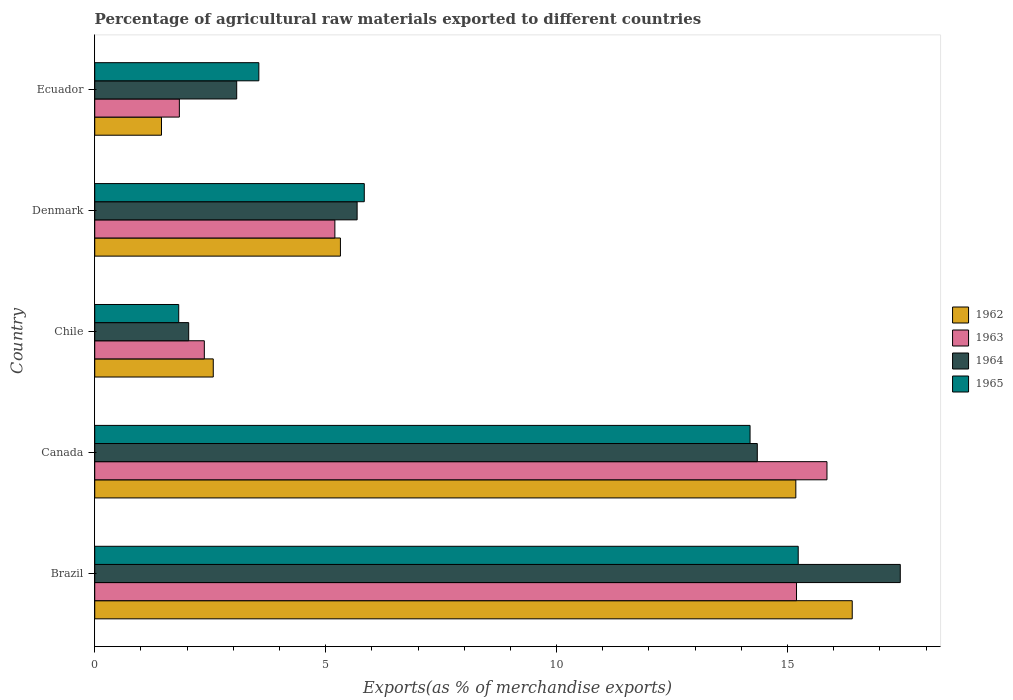How many different coloured bars are there?
Your answer should be very brief. 4. How many groups of bars are there?
Your response must be concise. 5. Are the number of bars on each tick of the Y-axis equal?
Provide a succinct answer. Yes. How many bars are there on the 1st tick from the top?
Offer a terse response. 4. How many bars are there on the 4th tick from the bottom?
Ensure brevity in your answer.  4. What is the label of the 3rd group of bars from the top?
Ensure brevity in your answer.  Chile. In how many cases, is the number of bars for a given country not equal to the number of legend labels?
Your answer should be compact. 0. What is the percentage of exports to different countries in 1965 in Canada?
Your response must be concise. 14.19. Across all countries, what is the maximum percentage of exports to different countries in 1962?
Your response must be concise. 16.4. Across all countries, what is the minimum percentage of exports to different countries in 1962?
Provide a succinct answer. 1.45. In which country was the percentage of exports to different countries in 1965 maximum?
Make the answer very short. Brazil. What is the total percentage of exports to different countries in 1963 in the graph?
Your answer should be compact. 40.46. What is the difference between the percentage of exports to different countries in 1965 in Brazil and that in Canada?
Ensure brevity in your answer.  1.04. What is the difference between the percentage of exports to different countries in 1962 in Chile and the percentage of exports to different countries in 1963 in Brazil?
Offer a terse response. -12.63. What is the average percentage of exports to different countries in 1964 per country?
Keep it short and to the point. 8.52. What is the difference between the percentage of exports to different countries in 1965 and percentage of exports to different countries in 1963 in Brazil?
Give a very brief answer. 0.04. What is the ratio of the percentage of exports to different countries in 1965 in Brazil to that in Ecuador?
Ensure brevity in your answer.  4.29. Is the percentage of exports to different countries in 1965 in Canada less than that in Denmark?
Ensure brevity in your answer.  No. Is the difference between the percentage of exports to different countries in 1965 in Brazil and Ecuador greater than the difference between the percentage of exports to different countries in 1963 in Brazil and Ecuador?
Offer a terse response. No. What is the difference between the highest and the second highest percentage of exports to different countries in 1965?
Your answer should be compact. 1.04. What is the difference between the highest and the lowest percentage of exports to different countries in 1962?
Offer a very short reply. 14.96. Is the sum of the percentage of exports to different countries in 1965 in Brazil and Chile greater than the maximum percentage of exports to different countries in 1964 across all countries?
Provide a short and direct response. No. Is it the case that in every country, the sum of the percentage of exports to different countries in 1963 and percentage of exports to different countries in 1965 is greater than the sum of percentage of exports to different countries in 1964 and percentage of exports to different countries in 1962?
Offer a very short reply. No. What does the 1st bar from the top in Denmark represents?
Provide a short and direct response. 1965. What does the 3rd bar from the bottom in Denmark represents?
Ensure brevity in your answer.  1964. How many bars are there?
Provide a short and direct response. 20. Are all the bars in the graph horizontal?
Your response must be concise. Yes. How many countries are there in the graph?
Provide a short and direct response. 5. What is the difference between two consecutive major ticks on the X-axis?
Make the answer very short. 5. Does the graph contain grids?
Provide a succinct answer. No. How are the legend labels stacked?
Provide a succinct answer. Vertical. What is the title of the graph?
Your response must be concise. Percentage of agricultural raw materials exported to different countries. Does "1984" appear as one of the legend labels in the graph?
Keep it short and to the point. No. What is the label or title of the X-axis?
Give a very brief answer. Exports(as % of merchandise exports). What is the Exports(as % of merchandise exports) of 1962 in Brazil?
Your answer should be very brief. 16.4. What is the Exports(as % of merchandise exports) in 1963 in Brazil?
Your response must be concise. 15.2. What is the Exports(as % of merchandise exports) of 1964 in Brazil?
Provide a succinct answer. 17.44. What is the Exports(as % of merchandise exports) of 1965 in Brazil?
Provide a short and direct response. 15.23. What is the Exports(as % of merchandise exports) of 1962 in Canada?
Provide a short and direct response. 15.18. What is the Exports(as % of merchandise exports) of 1963 in Canada?
Offer a very short reply. 15.85. What is the Exports(as % of merchandise exports) of 1964 in Canada?
Offer a terse response. 14.35. What is the Exports(as % of merchandise exports) of 1965 in Canada?
Offer a very short reply. 14.19. What is the Exports(as % of merchandise exports) of 1962 in Chile?
Your answer should be very brief. 2.57. What is the Exports(as % of merchandise exports) in 1963 in Chile?
Provide a short and direct response. 2.37. What is the Exports(as % of merchandise exports) in 1964 in Chile?
Offer a terse response. 2.03. What is the Exports(as % of merchandise exports) in 1965 in Chile?
Your answer should be very brief. 1.82. What is the Exports(as % of merchandise exports) in 1962 in Denmark?
Ensure brevity in your answer.  5.32. What is the Exports(as % of merchandise exports) in 1963 in Denmark?
Provide a succinct answer. 5.2. What is the Exports(as % of merchandise exports) in 1964 in Denmark?
Provide a short and direct response. 5.68. What is the Exports(as % of merchandise exports) in 1965 in Denmark?
Offer a very short reply. 5.84. What is the Exports(as % of merchandise exports) in 1962 in Ecuador?
Keep it short and to the point. 1.45. What is the Exports(as % of merchandise exports) in 1963 in Ecuador?
Give a very brief answer. 1.83. What is the Exports(as % of merchandise exports) of 1964 in Ecuador?
Give a very brief answer. 3.07. What is the Exports(as % of merchandise exports) of 1965 in Ecuador?
Make the answer very short. 3.55. Across all countries, what is the maximum Exports(as % of merchandise exports) of 1962?
Make the answer very short. 16.4. Across all countries, what is the maximum Exports(as % of merchandise exports) in 1963?
Ensure brevity in your answer.  15.85. Across all countries, what is the maximum Exports(as % of merchandise exports) in 1964?
Your answer should be compact. 17.44. Across all countries, what is the maximum Exports(as % of merchandise exports) in 1965?
Give a very brief answer. 15.23. Across all countries, what is the minimum Exports(as % of merchandise exports) in 1962?
Provide a short and direct response. 1.45. Across all countries, what is the minimum Exports(as % of merchandise exports) of 1963?
Make the answer very short. 1.83. Across all countries, what is the minimum Exports(as % of merchandise exports) of 1964?
Offer a terse response. 2.03. Across all countries, what is the minimum Exports(as % of merchandise exports) of 1965?
Ensure brevity in your answer.  1.82. What is the total Exports(as % of merchandise exports) in 1962 in the graph?
Your answer should be very brief. 40.91. What is the total Exports(as % of merchandise exports) of 1963 in the graph?
Offer a very short reply. 40.46. What is the total Exports(as % of merchandise exports) in 1964 in the graph?
Provide a short and direct response. 42.58. What is the total Exports(as % of merchandise exports) of 1965 in the graph?
Your answer should be compact. 40.63. What is the difference between the Exports(as % of merchandise exports) of 1962 in Brazil and that in Canada?
Keep it short and to the point. 1.22. What is the difference between the Exports(as % of merchandise exports) of 1963 in Brazil and that in Canada?
Your answer should be very brief. -0.66. What is the difference between the Exports(as % of merchandise exports) in 1964 in Brazil and that in Canada?
Make the answer very short. 3.1. What is the difference between the Exports(as % of merchandise exports) of 1965 in Brazil and that in Canada?
Provide a short and direct response. 1.04. What is the difference between the Exports(as % of merchandise exports) in 1962 in Brazil and that in Chile?
Offer a terse response. 13.84. What is the difference between the Exports(as % of merchandise exports) in 1963 in Brazil and that in Chile?
Offer a very short reply. 12.82. What is the difference between the Exports(as % of merchandise exports) of 1964 in Brazil and that in Chile?
Give a very brief answer. 15.41. What is the difference between the Exports(as % of merchandise exports) in 1965 in Brazil and that in Chile?
Keep it short and to the point. 13.41. What is the difference between the Exports(as % of merchandise exports) of 1962 in Brazil and that in Denmark?
Your response must be concise. 11.08. What is the difference between the Exports(as % of merchandise exports) in 1963 in Brazil and that in Denmark?
Offer a terse response. 10. What is the difference between the Exports(as % of merchandise exports) of 1964 in Brazil and that in Denmark?
Your response must be concise. 11.76. What is the difference between the Exports(as % of merchandise exports) in 1965 in Brazil and that in Denmark?
Ensure brevity in your answer.  9.4. What is the difference between the Exports(as % of merchandise exports) in 1962 in Brazil and that in Ecuador?
Your response must be concise. 14.96. What is the difference between the Exports(as % of merchandise exports) of 1963 in Brazil and that in Ecuador?
Keep it short and to the point. 13.36. What is the difference between the Exports(as % of merchandise exports) in 1964 in Brazil and that in Ecuador?
Provide a short and direct response. 14.37. What is the difference between the Exports(as % of merchandise exports) of 1965 in Brazil and that in Ecuador?
Your answer should be very brief. 11.68. What is the difference between the Exports(as % of merchandise exports) in 1962 in Canada and that in Chile?
Make the answer very short. 12.61. What is the difference between the Exports(as % of merchandise exports) in 1963 in Canada and that in Chile?
Provide a short and direct response. 13.48. What is the difference between the Exports(as % of merchandise exports) in 1964 in Canada and that in Chile?
Offer a terse response. 12.31. What is the difference between the Exports(as % of merchandise exports) in 1965 in Canada and that in Chile?
Your answer should be very brief. 12.37. What is the difference between the Exports(as % of merchandise exports) of 1962 in Canada and that in Denmark?
Ensure brevity in your answer.  9.86. What is the difference between the Exports(as % of merchandise exports) in 1963 in Canada and that in Denmark?
Your response must be concise. 10.65. What is the difference between the Exports(as % of merchandise exports) of 1964 in Canada and that in Denmark?
Keep it short and to the point. 8.66. What is the difference between the Exports(as % of merchandise exports) of 1965 in Canada and that in Denmark?
Provide a succinct answer. 8.35. What is the difference between the Exports(as % of merchandise exports) in 1962 in Canada and that in Ecuador?
Give a very brief answer. 13.74. What is the difference between the Exports(as % of merchandise exports) in 1963 in Canada and that in Ecuador?
Your response must be concise. 14.02. What is the difference between the Exports(as % of merchandise exports) in 1964 in Canada and that in Ecuador?
Make the answer very short. 11.27. What is the difference between the Exports(as % of merchandise exports) in 1965 in Canada and that in Ecuador?
Your response must be concise. 10.64. What is the difference between the Exports(as % of merchandise exports) in 1962 in Chile and that in Denmark?
Give a very brief answer. -2.75. What is the difference between the Exports(as % of merchandise exports) in 1963 in Chile and that in Denmark?
Give a very brief answer. -2.83. What is the difference between the Exports(as % of merchandise exports) in 1964 in Chile and that in Denmark?
Offer a terse response. -3.65. What is the difference between the Exports(as % of merchandise exports) of 1965 in Chile and that in Denmark?
Your response must be concise. -4.02. What is the difference between the Exports(as % of merchandise exports) in 1962 in Chile and that in Ecuador?
Keep it short and to the point. 1.12. What is the difference between the Exports(as % of merchandise exports) of 1963 in Chile and that in Ecuador?
Your response must be concise. 0.54. What is the difference between the Exports(as % of merchandise exports) of 1964 in Chile and that in Ecuador?
Ensure brevity in your answer.  -1.04. What is the difference between the Exports(as % of merchandise exports) in 1965 in Chile and that in Ecuador?
Your answer should be very brief. -1.74. What is the difference between the Exports(as % of merchandise exports) of 1962 in Denmark and that in Ecuador?
Offer a terse response. 3.87. What is the difference between the Exports(as % of merchandise exports) of 1963 in Denmark and that in Ecuador?
Offer a very short reply. 3.37. What is the difference between the Exports(as % of merchandise exports) of 1964 in Denmark and that in Ecuador?
Your response must be concise. 2.61. What is the difference between the Exports(as % of merchandise exports) of 1965 in Denmark and that in Ecuador?
Offer a terse response. 2.28. What is the difference between the Exports(as % of merchandise exports) of 1962 in Brazil and the Exports(as % of merchandise exports) of 1963 in Canada?
Provide a short and direct response. 0.55. What is the difference between the Exports(as % of merchandise exports) in 1962 in Brazil and the Exports(as % of merchandise exports) in 1964 in Canada?
Make the answer very short. 2.06. What is the difference between the Exports(as % of merchandise exports) in 1962 in Brazil and the Exports(as % of merchandise exports) in 1965 in Canada?
Keep it short and to the point. 2.21. What is the difference between the Exports(as % of merchandise exports) in 1963 in Brazil and the Exports(as % of merchandise exports) in 1964 in Canada?
Your answer should be compact. 0.85. What is the difference between the Exports(as % of merchandise exports) of 1963 in Brazil and the Exports(as % of merchandise exports) of 1965 in Canada?
Ensure brevity in your answer.  1.01. What is the difference between the Exports(as % of merchandise exports) of 1964 in Brazil and the Exports(as % of merchandise exports) of 1965 in Canada?
Give a very brief answer. 3.25. What is the difference between the Exports(as % of merchandise exports) in 1962 in Brazil and the Exports(as % of merchandise exports) in 1963 in Chile?
Make the answer very short. 14.03. What is the difference between the Exports(as % of merchandise exports) in 1962 in Brazil and the Exports(as % of merchandise exports) in 1964 in Chile?
Your answer should be compact. 14.37. What is the difference between the Exports(as % of merchandise exports) of 1962 in Brazil and the Exports(as % of merchandise exports) of 1965 in Chile?
Your response must be concise. 14.58. What is the difference between the Exports(as % of merchandise exports) in 1963 in Brazil and the Exports(as % of merchandise exports) in 1964 in Chile?
Keep it short and to the point. 13.16. What is the difference between the Exports(as % of merchandise exports) of 1963 in Brazil and the Exports(as % of merchandise exports) of 1965 in Chile?
Provide a short and direct response. 13.38. What is the difference between the Exports(as % of merchandise exports) in 1964 in Brazil and the Exports(as % of merchandise exports) in 1965 in Chile?
Ensure brevity in your answer.  15.62. What is the difference between the Exports(as % of merchandise exports) of 1962 in Brazil and the Exports(as % of merchandise exports) of 1963 in Denmark?
Give a very brief answer. 11.2. What is the difference between the Exports(as % of merchandise exports) in 1962 in Brazil and the Exports(as % of merchandise exports) in 1964 in Denmark?
Keep it short and to the point. 10.72. What is the difference between the Exports(as % of merchandise exports) of 1962 in Brazil and the Exports(as % of merchandise exports) of 1965 in Denmark?
Make the answer very short. 10.57. What is the difference between the Exports(as % of merchandise exports) of 1963 in Brazil and the Exports(as % of merchandise exports) of 1964 in Denmark?
Your answer should be very brief. 9.51. What is the difference between the Exports(as % of merchandise exports) of 1963 in Brazil and the Exports(as % of merchandise exports) of 1965 in Denmark?
Your response must be concise. 9.36. What is the difference between the Exports(as % of merchandise exports) in 1964 in Brazil and the Exports(as % of merchandise exports) in 1965 in Denmark?
Keep it short and to the point. 11.61. What is the difference between the Exports(as % of merchandise exports) of 1962 in Brazil and the Exports(as % of merchandise exports) of 1963 in Ecuador?
Offer a terse response. 14.57. What is the difference between the Exports(as % of merchandise exports) of 1962 in Brazil and the Exports(as % of merchandise exports) of 1964 in Ecuador?
Your answer should be compact. 13.33. What is the difference between the Exports(as % of merchandise exports) of 1962 in Brazil and the Exports(as % of merchandise exports) of 1965 in Ecuador?
Make the answer very short. 12.85. What is the difference between the Exports(as % of merchandise exports) in 1963 in Brazil and the Exports(as % of merchandise exports) in 1964 in Ecuador?
Your response must be concise. 12.12. What is the difference between the Exports(as % of merchandise exports) in 1963 in Brazil and the Exports(as % of merchandise exports) in 1965 in Ecuador?
Keep it short and to the point. 11.64. What is the difference between the Exports(as % of merchandise exports) of 1964 in Brazil and the Exports(as % of merchandise exports) of 1965 in Ecuador?
Ensure brevity in your answer.  13.89. What is the difference between the Exports(as % of merchandise exports) in 1962 in Canada and the Exports(as % of merchandise exports) in 1963 in Chile?
Your answer should be very brief. 12.81. What is the difference between the Exports(as % of merchandise exports) in 1962 in Canada and the Exports(as % of merchandise exports) in 1964 in Chile?
Provide a succinct answer. 13.15. What is the difference between the Exports(as % of merchandise exports) of 1962 in Canada and the Exports(as % of merchandise exports) of 1965 in Chile?
Provide a short and direct response. 13.36. What is the difference between the Exports(as % of merchandise exports) of 1963 in Canada and the Exports(as % of merchandise exports) of 1964 in Chile?
Provide a short and direct response. 13.82. What is the difference between the Exports(as % of merchandise exports) in 1963 in Canada and the Exports(as % of merchandise exports) in 1965 in Chile?
Offer a terse response. 14.04. What is the difference between the Exports(as % of merchandise exports) in 1964 in Canada and the Exports(as % of merchandise exports) in 1965 in Chile?
Keep it short and to the point. 12.53. What is the difference between the Exports(as % of merchandise exports) of 1962 in Canada and the Exports(as % of merchandise exports) of 1963 in Denmark?
Give a very brief answer. 9.98. What is the difference between the Exports(as % of merchandise exports) of 1962 in Canada and the Exports(as % of merchandise exports) of 1964 in Denmark?
Your response must be concise. 9.5. What is the difference between the Exports(as % of merchandise exports) of 1962 in Canada and the Exports(as % of merchandise exports) of 1965 in Denmark?
Your answer should be compact. 9.34. What is the difference between the Exports(as % of merchandise exports) in 1963 in Canada and the Exports(as % of merchandise exports) in 1964 in Denmark?
Provide a succinct answer. 10.17. What is the difference between the Exports(as % of merchandise exports) of 1963 in Canada and the Exports(as % of merchandise exports) of 1965 in Denmark?
Offer a very short reply. 10.02. What is the difference between the Exports(as % of merchandise exports) in 1964 in Canada and the Exports(as % of merchandise exports) in 1965 in Denmark?
Keep it short and to the point. 8.51. What is the difference between the Exports(as % of merchandise exports) in 1962 in Canada and the Exports(as % of merchandise exports) in 1963 in Ecuador?
Keep it short and to the point. 13.35. What is the difference between the Exports(as % of merchandise exports) in 1962 in Canada and the Exports(as % of merchandise exports) in 1964 in Ecuador?
Offer a terse response. 12.11. What is the difference between the Exports(as % of merchandise exports) of 1962 in Canada and the Exports(as % of merchandise exports) of 1965 in Ecuador?
Provide a succinct answer. 11.63. What is the difference between the Exports(as % of merchandise exports) in 1963 in Canada and the Exports(as % of merchandise exports) in 1964 in Ecuador?
Make the answer very short. 12.78. What is the difference between the Exports(as % of merchandise exports) in 1963 in Canada and the Exports(as % of merchandise exports) in 1965 in Ecuador?
Offer a terse response. 12.3. What is the difference between the Exports(as % of merchandise exports) in 1964 in Canada and the Exports(as % of merchandise exports) in 1965 in Ecuador?
Offer a terse response. 10.79. What is the difference between the Exports(as % of merchandise exports) in 1962 in Chile and the Exports(as % of merchandise exports) in 1963 in Denmark?
Your answer should be compact. -2.63. What is the difference between the Exports(as % of merchandise exports) of 1962 in Chile and the Exports(as % of merchandise exports) of 1964 in Denmark?
Provide a short and direct response. -3.11. What is the difference between the Exports(as % of merchandise exports) in 1962 in Chile and the Exports(as % of merchandise exports) in 1965 in Denmark?
Your response must be concise. -3.27. What is the difference between the Exports(as % of merchandise exports) in 1963 in Chile and the Exports(as % of merchandise exports) in 1964 in Denmark?
Give a very brief answer. -3.31. What is the difference between the Exports(as % of merchandise exports) of 1963 in Chile and the Exports(as % of merchandise exports) of 1965 in Denmark?
Make the answer very short. -3.46. What is the difference between the Exports(as % of merchandise exports) in 1964 in Chile and the Exports(as % of merchandise exports) in 1965 in Denmark?
Provide a succinct answer. -3.8. What is the difference between the Exports(as % of merchandise exports) in 1962 in Chile and the Exports(as % of merchandise exports) in 1963 in Ecuador?
Your response must be concise. 0.73. What is the difference between the Exports(as % of merchandise exports) of 1962 in Chile and the Exports(as % of merchandise exports) of 1964 in Ecuador?
Your response must be concise. -0.51. What is the difference between the Exports(as % of merchandise exports) of 1962 in Chile and the Exports(as % of merchandise exports) of 1965 in Ecuador?
Keep it short and to the point. -0.99. What is the difference between the Exports(as % of merchandise exports) of 1963 in Chile and the Exports(as % of merchandise exports) of 1964 in Ecuador?
Offer a very short reply. -0.7. What is the difference between the Exports(as % of merchandise exports) of 1963 in Chile and the Exports(as % of merchandise exports) of 1965 in Ecuador?
Offer a very short reply. -1.18. What is the difference between the Exports(as % of merchandise exports) in 1964 in Chile and the Exports(as % of merchandise exports) in 1965 in Ecuador?
Your answer should be compact. -1.52. What is the difference between the Exports(as % of merchandise exports) in 1962 in Denmark and the Exports(as % of merchandise exports) in 1963 in Ecuador?
Your answer should be compact. 3.49. What is the difference between the Exports(as % of merchandise exports) in 1962 in Denmark and the Exports(as % of merchandise exports) in 1964 in Ecuador?
Your answer should be compact. 2.25. What is the difference between the Exports(as % of merchandise exports) in 1962 in Denmark and the Exports(as % of merchandise exports) in 1965 in Ecuador?
Your answer should be very brief. 1.77. What is the difference between the Exports(as % of merchandise exports) of 1963 in Denmark and the Exports(as % of merchandise exports) of 1964 in Ecuador?
Provide a succinct answer. 2.13. What is the difference between the Exports(as % of merchandise exports) in 1963 in Denmark and the Exports(as % of merchandise exports) in 1965 in Ecuador?
Your answer should be very brief. 1.65. What is the difference between the Exports(as % of merchandise exports) in 1964 in Denmark and the Exports(as % of merchandise exports) in 1965 in Ecuador?
Your answer should be compact. 2.13. What is the average Exports(as % of merchandise exports) in 1962 per country?
Your answer should be compact. 8.18. What is the average Exports(as % of merchandise exports) of 1963 per country?
Provide a short and direct response. 8.09. What is the average Exports(as % of merchandise exports) in 1964 per country?
Give a very brief answer. 8.52. What is the average Exports(as % of merchandise exports) in 1965 per country?
Your response must be concise. 8.13. What is the difference between the Exports(as % of merchandise exports) in 1962 and Exports(as % of merchandise exports) in 1963 in Brazil?
Provide a short and direct response. 1.21. What is the difference between the Exports(as % of merchandise exports) in 1962 and Exports(as % of merchandise exports) in 1964 in Brazil?
Ensure brevity in your answer.  -1.04. What is the difference between the Exports(as % of merchandise exports) in 1962 and Exports(as % of merchandise exports) in 1965 in Brazil?
Provide a short and direct response. 1.17. What is the difference between the Exports(as % of merchandise exports) in 1963 and Exports(as % of merchandise exports) in 1964 in Brazil?
Make the answer very short. -2.25. What is the difference between the Exports(as % of merchandise exports) of 1963 and Exports(as % of merchandise exports) of 1965 in Brazil?
Offer a very short reply. -0.04. What is the difference between the Exports(as % of merchandise exports) in 1964 and Exports(as % of merchandise exports) in 1965 in Brazil?
Ensure brevity in your answer.  2.21. What is the difference between the Exports(as % of merchandise exports) of 1962 and Exports(as % of merchandise exports) of 1963 in Canada?
Your response must be concise. -0.67. What is the difference between the Exports(as % of merchandise exports) in 1962 and Exports(as % of merchandise exports) in 1964 in Canada?
Offer a very short reply. 0.83. What is the difference between the Exports(as % of merchandise exports) in 1963 and Exports(as % of merchandise exports) in 1964 in Canada?
Provide a short and direct response. 1.51. What is the difference between the Exports(as % of merchandise exports) of 1963 and Exports(as % of merchandise exports) of 1965 in Canada?
Keep it short and to the point. 1.67. What is the difference between the Exports(as % of merchandise exports) of 1964 and Exports(as % of merchandise exports) of 1965 in Canada?
Keep it short and to the point. 0.16. What is the difference between the Exports(as % of merchandise exports) of 1962 and Exports(as % of merchandise exports) of 1963 in Chile?
Give a very brief answer. 0.19. What is the difference between the Exports(as % of merchandise exports) of 1962 and Exports(as % of merchandise exports) of 1964 in Chile?
Give a very brief answer. 0.53. What is the difference between the Exports(as % of merchandise exports) in 1962 and Exports(as % of merchandise exports) in 1965 in Chile?
Your answer should be very brief. 0.75. What is the difference between the Exports(as % of merchandise exports) in 1963 and Exports(as % of merchandise exports) in 1964 in Chile?
Provide a succinct answer. 0.34. What is the difference between the Exports(as % of merchandise exports) in 1963 and Exports(as % of merchandise exports) in 1965 in Chile?
Give a very brief answer. 0.55. What is the difference between the Exports(as % of merchandise exports) of 1964 and Exports(as % of merchandise exports) of 1965 in Chile?
Offer a terse response. 0.22. What is the difference between the Exports(as % of merchandise exports) in 1962 and Exports(as % of merchandise exports) in 1963 in Denmark?
Make the answer very short. 0.12. What is the difference between the Exports(as % of merchandise exports) in 1962 and Exports(as % of merchandise exports) in 1964 in Denmark?
Your answer should be compact. -0.36. What is the difference between the Exports(as % of merchandise exports) in 1962 and Exports(as % of merchandise exports) in 1965 in Denmark?
Give a very brief answer. -0.52. What is the difference between the Exports(as % of merchandise exports) of 1963 and Exports(as % of merchandise exports) of 1964 in Denmark?
Your response must be concise. -0.48. What is the difference between the Exports(as % of merchandise exports) in 1963 and Exports(as % of merchandise exports) in 1965 in Denmark?
Provide a succinct answer. -0.64. What is the difference between the Exports(as % of merchandise exports) in 1964 and Exports(as % of merchandise exports) in 1965 in Denmark?
Offer a terse response. -0.15. What is the difference between the Exports(as % of merchandise exports) in 1962 and Exports(as % of merchandise exports) in 1963 in Ecuador?
Your response must be concise. -0.39. What is the difference between the Exports(as % of merchandise exports) in 1962 and Exports(as % of merchandise exports) in 1964 in Ecuador?
Ensure brevity in your answer.  -1.63. What is the difference between the Exports(as % of merchandise exports) in 1962 and Exports(as % of merchandise exports) in 1965 in Ecuador?
Provide a short and direct response. -2.11. What is the difference between the Exports(as % of merchandise exports) of 1963 and Exports(as % of merchandise exports) of 1964 in Ecuador?
Your answer should be very brief. -1.24. What is the difference between the Exports(as % of merchandise exports) in 1963 and Exports(as % of merchandise exports) in 1965 in Ecuador?
Offer a terse response. -1.72. What is the difference between the Exports(as % of merchandise exports) of 1964 and Exports(as % of merchandise exports) of 1965 in Ecuador?
Offer a very short reply. -0.48. What is the ratio of the Exports(as % of merchandise exports) in 1962 in Brazil to that in Canada?
Keep it short and to the point. 1.08. What is the ratio of the Exports(as % of merchandise exports) of 1963 in Brazil to that in Canada?
Your answer should be very brief. 0.96. What is the ratio of the Exports(as % of merchandise exports) of 1964 in Brazil to that in Canada?
Offer a terse response. 1.22. What is the ratio of the Exports(as % of merchandise exports) of 1965 in Brazil to that in Canada?
Your answer should be very brief. 1.07. What is the ratio of the Exports(as % of merchandise exports) in 1962 in Brazil to that in Chile?
Your answer should be very brief. 6.39. What is the ratio of the Exports(as % of merchandise exports) of 1963 in Brazil to that in Chile?
Ensure brevity in your answer.  6.4. What is the ratio of the Exports(as % of merchandise exports) of 1964 in Brazil to that in Chile?
Provide a short and direct response. 8.57. What is the ratio of the Exports(as % of merchandise exports) in 1965 in Brazil to that in Chile?
Give a very brief answer. 8.38. What is the ratio of the Exports(as % of merchandise exports) in 1962 in Brazil to that in Denmark?
Your answer should be very brief. 3.08. What is the ratio of the Exports(as % of merchandise exports) of 1963 in Brazil to that in Denmark?
Your answer should be very brief. 2.92. What is the ratio of the Exports(as % of merchandise exports) of 1964 in Brazil to that in Denmark?
Offer a terse response. 3.07. What is the ratio of the Exports(as % of merchandise exports) in 1965 in Brazil to that in Denmark?
Your response must be concise. 2.61. What is the ratio of the Exports(as % of merchandise exports) of 1962 in Brazil to that in Ecuador?
Provide a succinct answer. 11.35. What is the ratio of the Exports(as % of merchandise exports) in 1963 in Brazil to that in Ecuador?
Give a very brief answer. 8.29. What is the ratio of the Exports(as % of merchandise exports) in 1964 in Brazil to that in Ecuador?
Provide a short and direct response. 5.67. What is the ratio of the Exports(as % of merchandise exports) in 1965 in Brazil to that in Ecuador?
Make the answer very short. 4.29. What is the ratio of the Exports(as % of merchandise exports) of 1962 in Canada to that in Chile?
Provide a short and direct response. 5.91. What is the ratio of the Exports(as % of merchandise exports) in 1963 in Canada to that in Chile?
Ensure brevity in your answer.  6.68. What is the ratio of the Exports(as % of merchandise exports) in 1964 in Canada to that in Chile?
Offer a very short reply. 7.05. What is the ratio of the Exports(as % of merchandise exports) of 1965 in Canada to that in Chile?
Offer a very short reply. 7.8. What is the ratio of the Exports(as % of merchandise exports) in 1962 in Canada to that in Denmark?
Your answer should be compact. 2.85. What is the ratio of the Exports(as % of merchandise exports) of 1963 in Canada to that in Denmark?
Your answer should be compact. 3.05. What is the ratio of the Exports(as % of merchandise exports) of 1964 in Canada to that in Denmark?
Keep it short and to the point. 2.53. What is the ratio of the Exports(as % of merchandise exports) in 1965 in Canada to that in Denmark?
Offer a terse response. 2.43. What is the ratio of the Exports(as % of merchandise exports) in 1962 in Canada to that in Ecuador?
Keep it short and to the point. 10.5. What is the ratio of the Exports(as % of merchandise exports) of 1963 in Canada to that in Ecuador?
Your answer should be very brief. 8.65. What is the ratio of the Exports(as % of merchandise exports) in 1964 in Canada to that in Ecuador?
Keep it short and to the point. 4.67. What is the ratio of the Exports(as % of merchandise exports) of 1965 in Canada to that in Ecuador?
Offer a terse response. 3.99. What is the ratio of the Exports(as % of merchandise exports) in 1962 in Chile to that in Denmark?
Provide a succinct answer. 0.48. What is the ratio of the Exports(as % of merchandise exports) in 1963 in Chile to that in Denmark?
Give a very brief answer. 0.46. What is the ratio of the Exports(as % of merchandise exports) in 1964 in Chile to that in Denmark?
Make the answer very short. 0.36. What is the ratio of the Exports(as % of merchandise exports) in 1965 in Chile to that in Denmark?
Make the answer very short. 0.31. What is the ratio of the Exports(as % of merchandise exports) in 1962 in Chile to that in Ecuador?
Offer a very short reply. 1.78. What is the ratio of the Exports(as % of merchandise exports) of 1963 in Chile to that in Ecuador?
Provide a short and direct response. 1.3. What is the ratio of the Exports(as % of merchandise exports) in 1964 in Chile to that in Ecuador?
Provide a succinct answer. 0.66. What is the ratio of the Exports(as % of merchandise exports) in 1965 in Chile to that in Ecuador?
Your response must be concise. 0.51. What is the ratio of the Exports(as % of merchandise exports) of 1962 in Denmark to that in Ecuador?
Offer a very short reply. 3.68. What is the ratio of the Exports(as % of merchandise exports) of 1963 in Denmark to that in Ecuador?
Your answer should be very brief. 2.84. What is the ratio of the Exports(as % of merchandise exports) in 1964 in Denmark to that in Ecuador?
Your answer should be very brief. 1.85. What is the ratio of the Exports(as % of merchandise exports) of 1965 in Denmark to that in Ecuador?
Offer a very short reply. 1.64. What is the difference between the highest and the second highest Exports(as % of merchandise exports) in 1962?
Keep it short and to the point. 1.22. What is the difference between the highest and the second highest Exports(as % of merchandise exports) in 1963?
Make the answer very short. 0.66. What is the difference between the highest and the second highest Exports(as % of merchandise exports) of 1964?
Provide a short and direct response. 3.1. What is the difference between the highest and the second highest Exports(as % of merchandise exports) of 1965?
Provide a succinct answer. 1.04. What is the difference between the highest and the lowest Exports(as % of merchandise exports) of 1962?
Keep it short and to the point. 14.96. What is the difference between the highest and the lowest Exports(as % of merchandise exports) of 1963?
Provide a short and direct response. 14.02. What is the difference between the highest and the lowest Exports(as % of merchandise exports) of 1964?
Provide a short and direct response. 15.41. What is the difference between the highest and the lowest Exports(as % of merchandise exports) of 1965?
Keep it short and to the point. 13.41. 